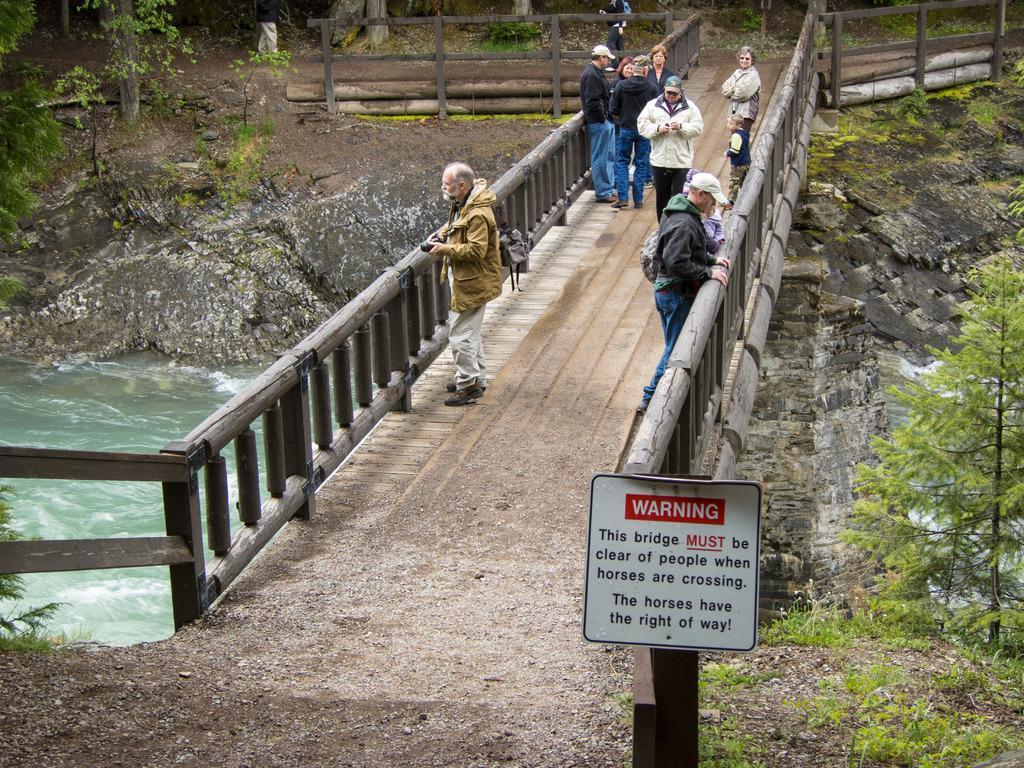How would you summarize this image in a sentence or two? In this image we can see some persons, bridge, board and other objects. In the background of the image there are trees, wooden fence, persons and other objects. On the left side of the image there is water and an object. On the right side of the image there are rocks, plants and other objects. At the bottom of the image there is the ground. 